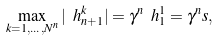Convert formula to latex. <formula><loc_0><loc_0><loc_500><loc_500>\max _ { k = 1 , \dots , N ^ { n } } | \ h _ { n + 1 } ^ { k } | = \gamma ^ { n } \ h _ { 1 } ^ { 1 } = \gamma ^ { n } s ,</formula> 